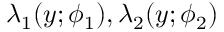<formula> <loc_0><loc_0><loc_500><loc_500>\lambda _ { 1 } ( y ; \phi _ { 1 } ) , \lambda _ { 2 } ( y ; \phi _ { 2 } )</formula> 